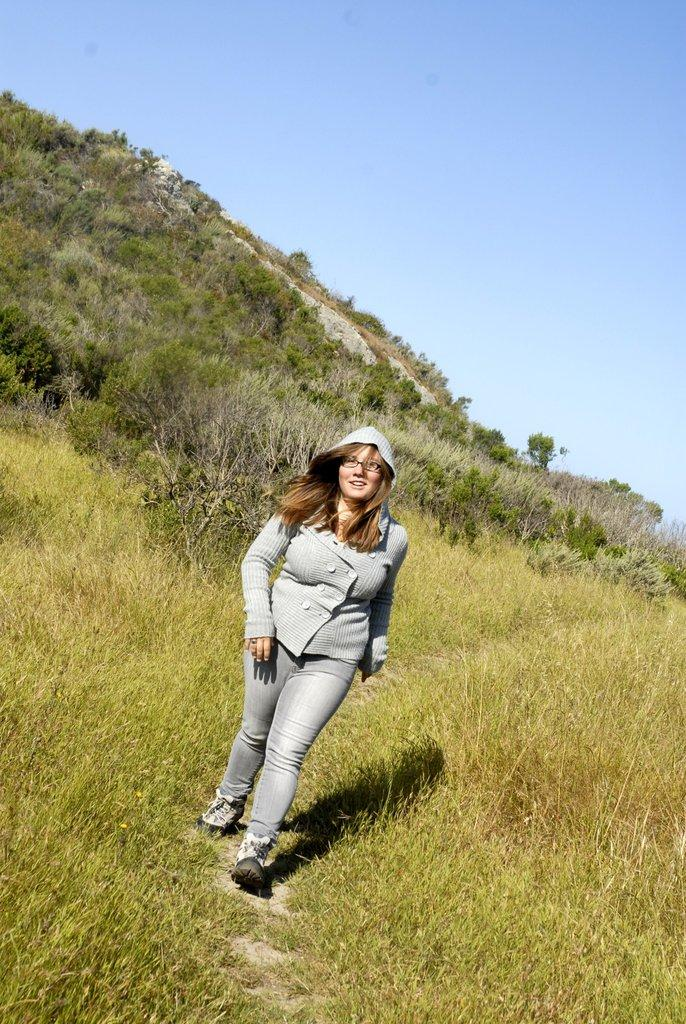What is the lady in the image doing? The lady is walking in the image. What type of terrain is visible at the bottom of the image? There is grass at the bottom of the image. What can be seen in the background of the image? There is a mountain, trees, and the sky visible in the background of the image. What type of engine can be seen powering the chair in the image? There is no chair or engine present in the image. What does the lady need to continue walking in the image? The lady does not need anything to continue walking in the image, as she is already walking. 